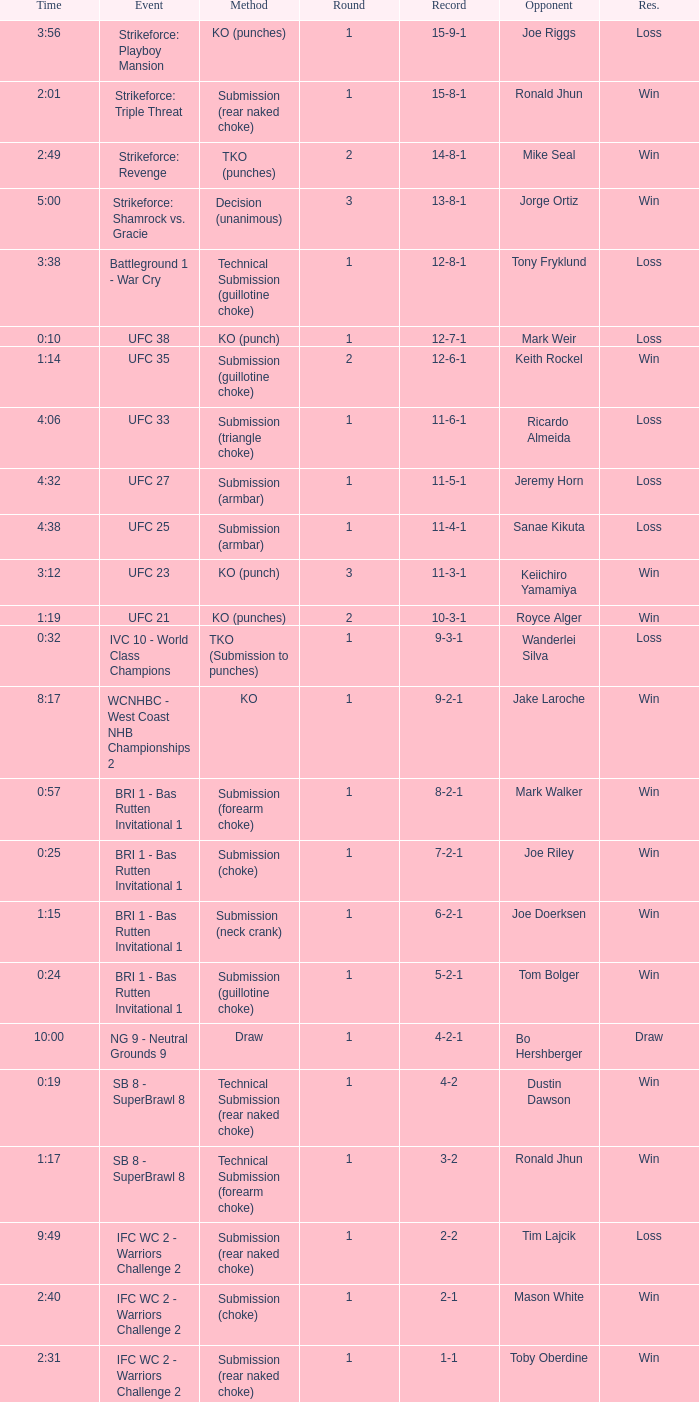Who was the opponent when the fight had a time of 2:01? Ronald Jhun. 